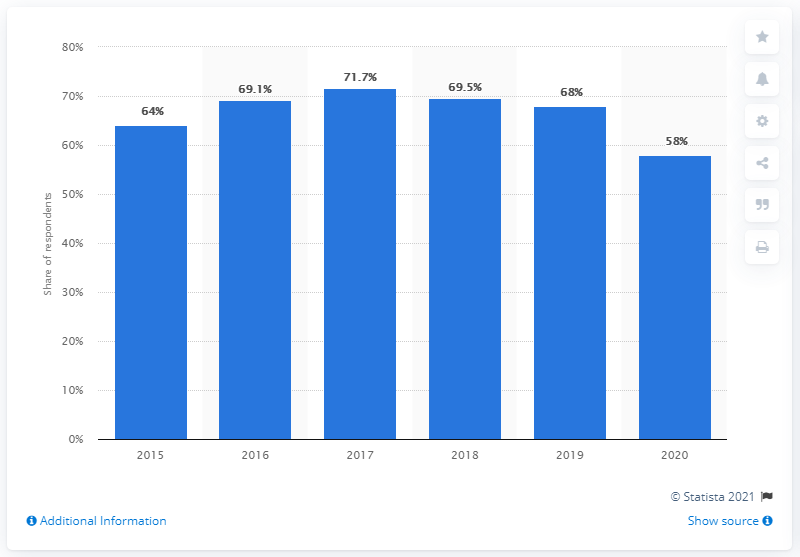List a handful of essential elements in this visual. According to a survey conducted in 2020, 58% of Americans planned to participate in Halloween celebrations. 